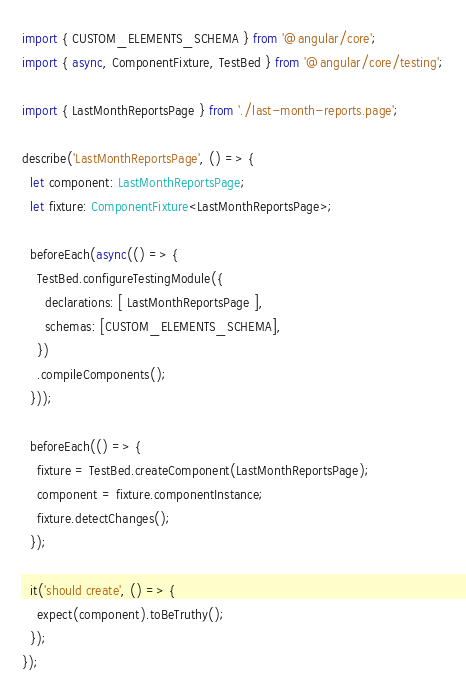<code> <loc_0><loc_0><loc_500><loc_500><_TypeScript_>import { CUSTOM_ELEMENTS_SCHEMA } from '@angular/core';
import { async, ComponentFixture, TestBed } from '@angular/core/testing';

import { LastMonthReportsPage } from './last-month-reports.page';

describe('LastMonthReportsPage', () => {
  let component: LastMonthReportsPage;
  let fixture: ComponentFixture<LastMonthReportsPage>;

  beforeEach(async(() => {
    TestBed.configureTestingModule({
      declarations: [ LastMonthReportsPage ],
      schemas: [CUSTOM_ELEMENTS_SCHEMA],
    })
    .compileComponents();
  }));

  beforeEach(() => {
    fixture = TestBed.createComponent(LastMonthReportsPage);
    component = fixture.componentInstance;
    fixture.detectChanges();
  });

  it('should create', () => {
    expect(component).toBeTruthy();
  });
});
</code> 